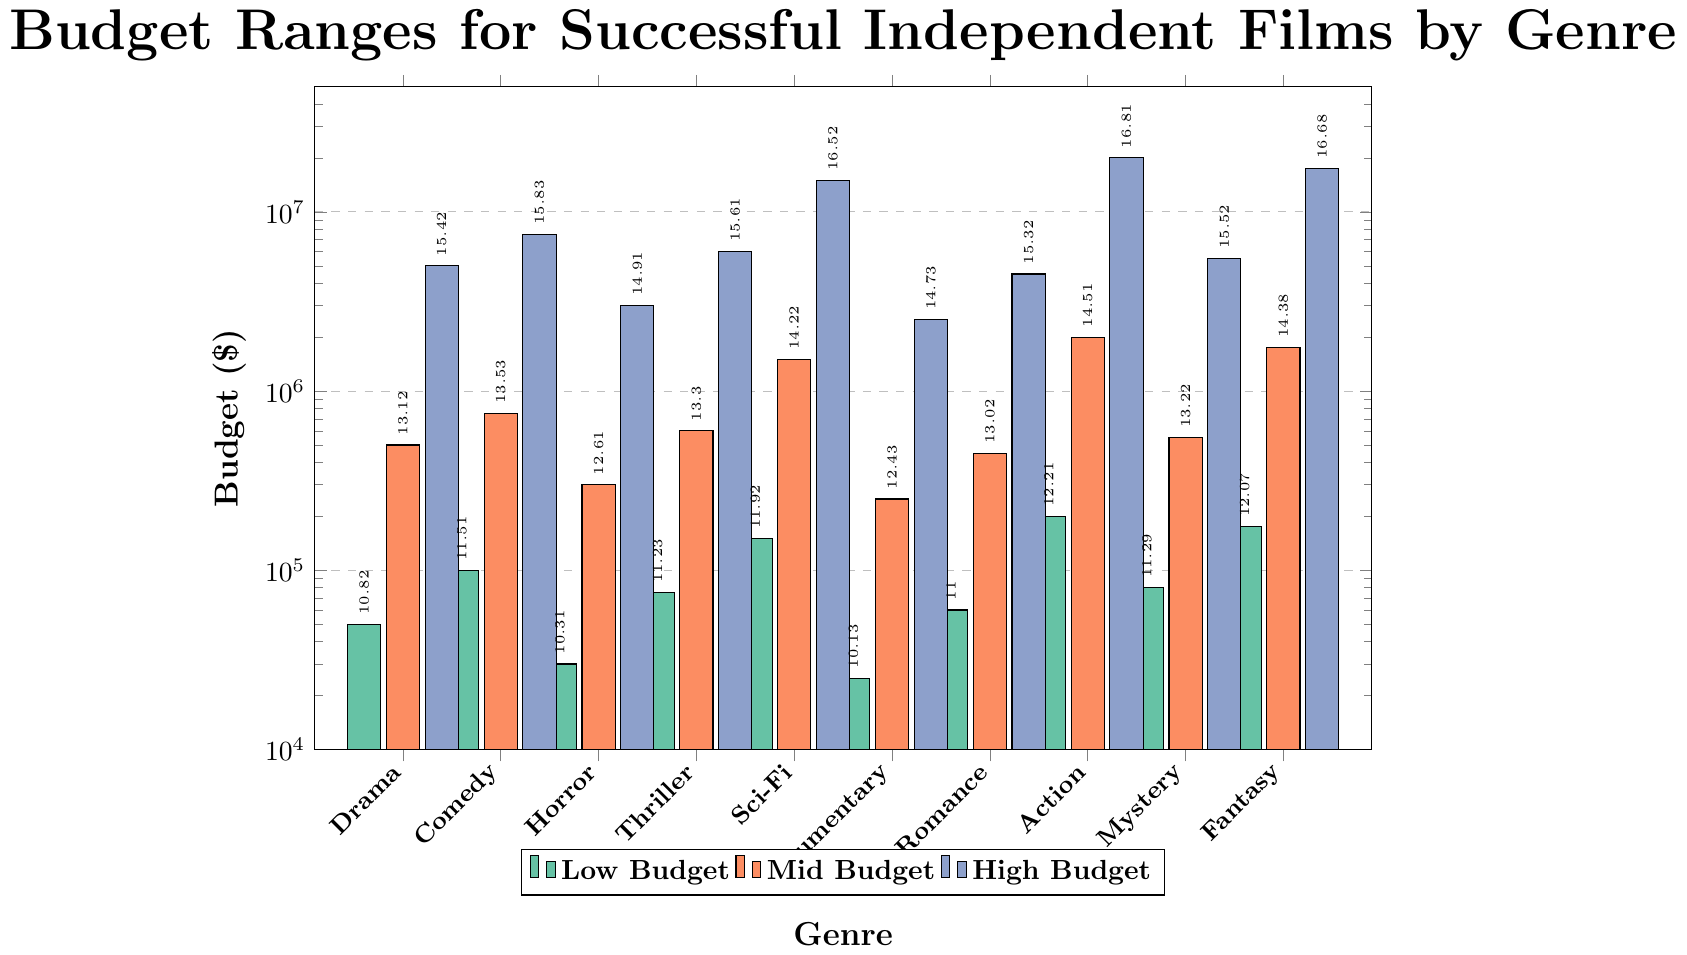Which genre has the highest low budget value? For the low budget category, the bar for Action has the highest value.
Answer: Action How many genres have a mid budget value of at least 1,000,000? Check the mid budget values for each genre and count those with values 1,000,000 or higher: Sci-Fi, Action, and Fantasy.
Answer: 3 What is the difference in high budget values between Comedy and Documentary? The high budget value for Comedy is 7,500,000 and for Documentary is 2,500,000. The difference is 7,500,000 - 2,500,000.
Answer: 5,000,000 Which genre has the smallest low budget value? For the low budget category, the bar for Documentary has the smallest value.
Answer: Documentary What is the sum of mid budget values for Drama and Romance? Add the mid budget values for Drama (500,000) and Romance (450,000): 500,000 + 450,000.
Answer: 950,000 Compare the high budget values of Sci-Fi and Fantasy. Which one is larger, and by how much? The high budget value for Sci-Fi is 15,000,000, and for Fantasy is 17,500,000. Fantasy is larger by 2,500,000 (17,500,000 - 15,000,000).
Answer: Fantasy, 2,500,000 Which three genres have the highest mid budget values? The three highest mid budget values are observed in Action (2,000,000), Sci-Fi (1,500,000), and Fantasy (1,750,000).
Answer: Action, Sci-Fi, Fantasy What is the average high budget value across all genres? Sum all high budget values and divide by the number of genres: \( (5,000,000 + 7,500,000 + 3,000,000 + 6,000,000 + 15,000,000 + 2,500,000 + 4,500,000 + 20,000,000 + 5,500,000 + 17,500,000) / 10 \).
Answer: 8,500,000 Which genre has the highest value across all categories and what is that value? Action has the highest high budget value of 20,000,000, which is the greatest across all categories.
Answer: Action, 20,000,000 Identify the genre with the largest range between low and high budget values. Calculate the ranges and compare: Action (20,000,000 - 200,000), Fantasy (17,500,000 - 175,000), and Sci-Fi (15,000,000 - 150,000). Action has the largest range of 19,800,000.
Answer: Action 